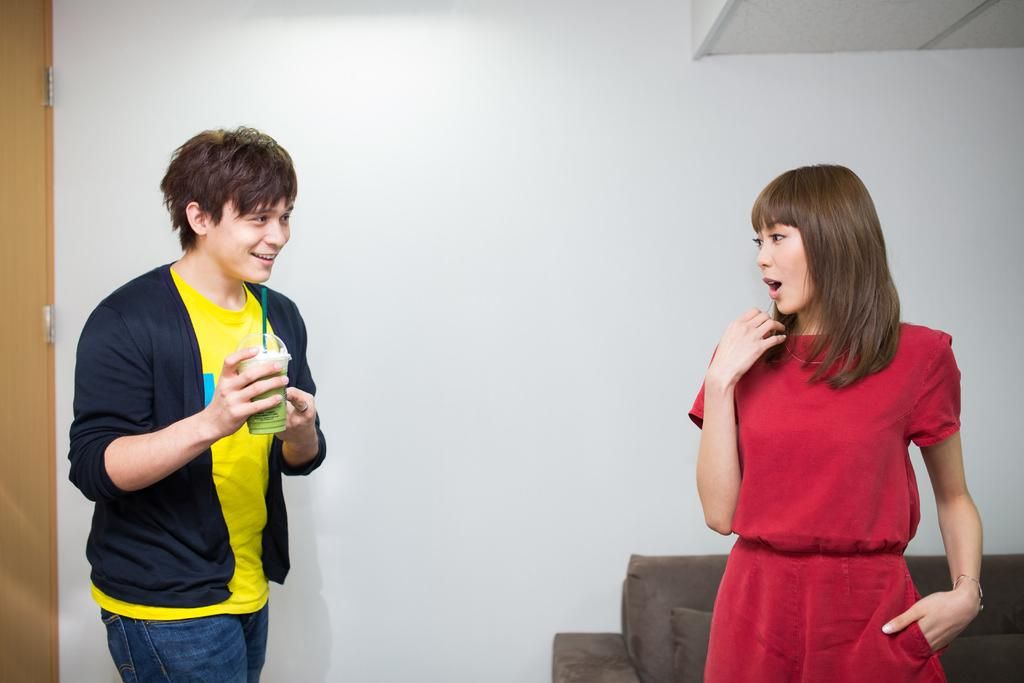Who are the people in the image? There is a man and a woman standing in the image. What is the man holding in the image? The man is holding a glass with a straw. What can be seen in the background of the image? There is a couch, a door, and a wall visible in the background of the image. What type of plants can be seen growing on the man's ear in the image? There are no plants visible on the man's ear in the image. 